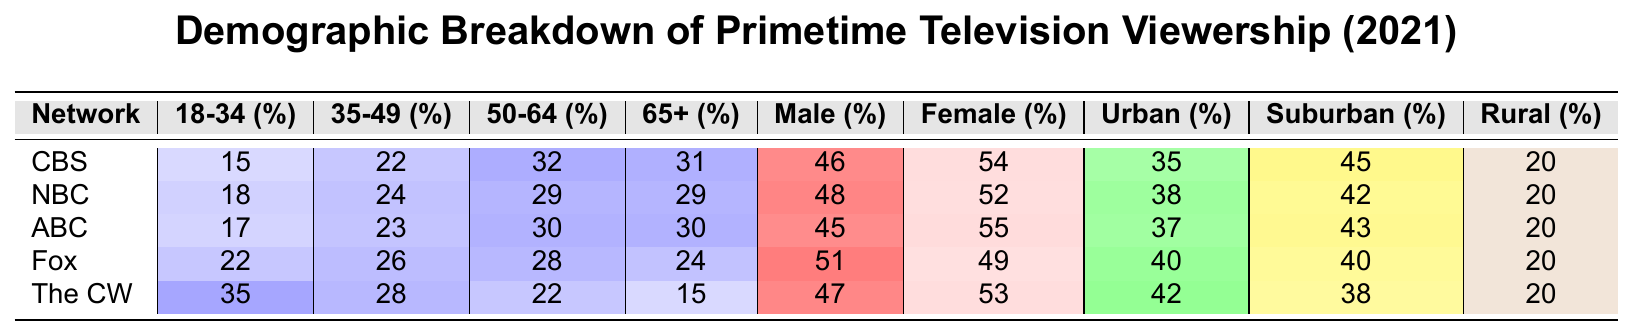What percentage of viewership for CBS is aged 18-34? The table shows that CBS has 15% of its viewership in the 18-34 age group.
Answer: 15% Which network has the highest percentage of viewers aged 65 and older? The table indicates that CBS and NBC both have 29% for viewers aged 65 and older, while other networks have lower percentages.
Answer: CBS and NBC (29%) What is the percentage of female viewers for ABC? According to the table, ABC has 55% female viewership.
Answer: 55% Which network has the largest percentage of viewers in the 35-49 age category? The table shows NBC has the highest percentage at 24% in the 35-49 age category.
Answer: NBC (24%) Is the percentage of male viewers for Fox higher than that for CBS? Fox has 51% male viewers while CBS has 46%, so Fox does have a higher percentage.
Answer: Yes What is the difference in percentage points of viewers aged 50-64 between NBC and The CW? NBC has 29% and The CW has 22% for the 50-64 age group; the difference is 29 - 22 = 7 percentage points.
Answer: 7 Which network has a higher percentage of urban viewers, CBS or ABC? CBS has 35% urban viewers while ABC has 37%, thus ABC has a higher percentage of urban viewers.
Answer: ABC Calculate the average percentage of viewers aged 18-34 across all networks. The percentages for 18-34 viewers are 15 (CBS) + 18 (NBC) + 17 (ABC) + 22 (Fox) + 35 (The CW) = 107. Dividing by 5 networks gives an average of 107/5 = 21.4.
Answer: 21.4 Compared to The CW, does NBC have a lower percentage of rural viewers? The CW has 20% rural viewers and NBC also has 20%. Therefore, NBC does not have a lower percentage than The CW.
Answer: No What network has the highest percentage of viewers in the age group 65 and older? CBS has the highest percentage of viewers aged 65 and older at 31%.
Answer: CBS (31%) 